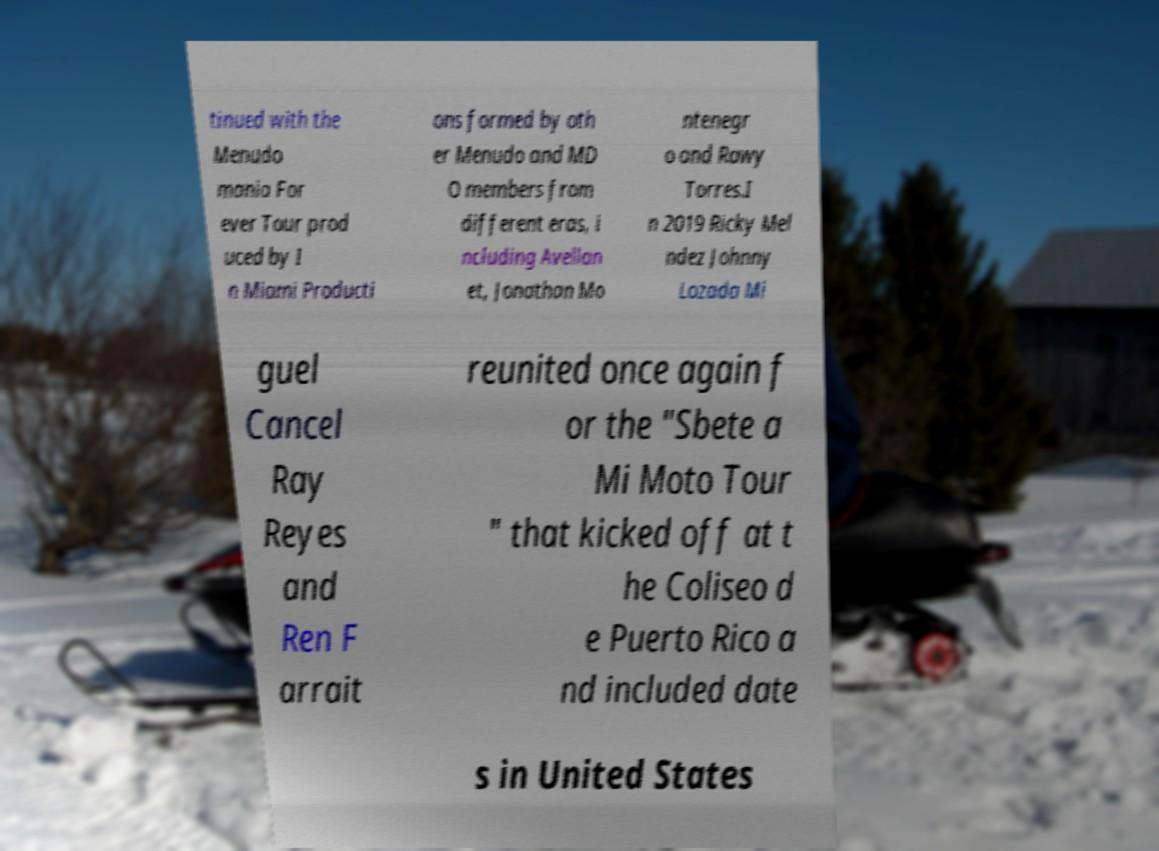Could you extract and type out the text from this image? tinued with the Menudo mania For ever Tour prod uced by I n Miami Producti ons formed by oth er Menudo and MD O members from different eras, i ncluding Avellan et, Jonathan Mo ntenegr o and Rawy Torres.I n 2019 Ricky Mel ndez Johnny Lozada Mi guel Cancel Ray Reyes and Ren F arrait reunited once again f or the "Sbete a Mi Moto Tour " that kicked off at t he Coliseo d e Puerto Rico a nd included date s in United States 